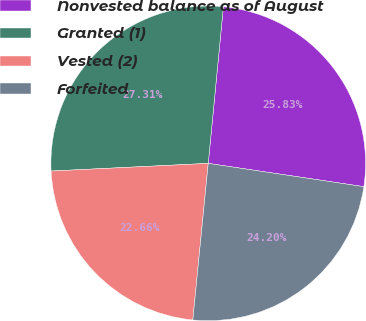Convert chart to OTSL. <chart><loc_0><loc_0><loc_500><loc_500><pie_chart><fcel>Nonvested balance as of August<fcel>Granted (1)<fcel>Vested (2)<fcel>Forfeited<nl><fcel>25.83%<fcel>27.31%<fcel>22.66%<fcel>24.2%<nl></chart> 